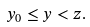Convert formula to latex. <formula><loc_0><loc_0><loc_500><loc_500>y _ { 0 } \leq y < z .</formula> 